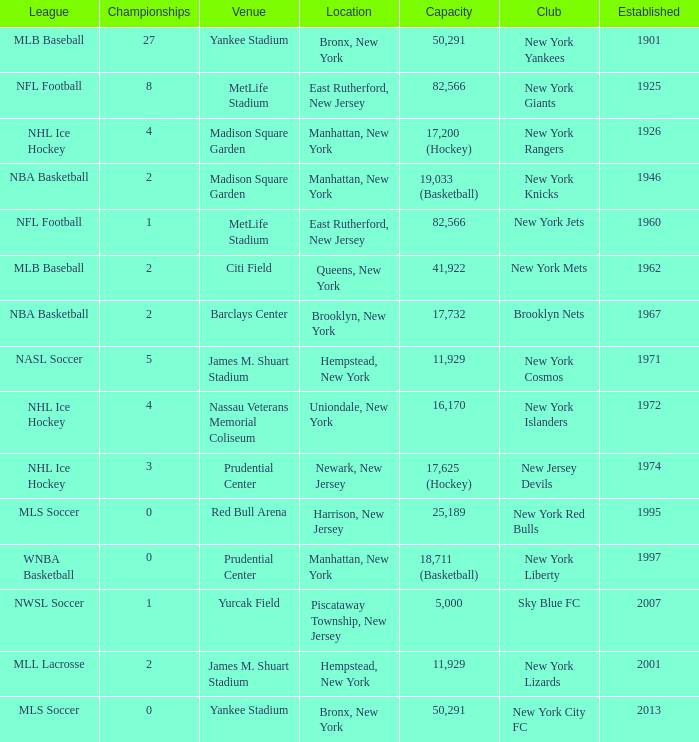When was the venue named nassau veterans memorial coliseum established?? 1972.0. 